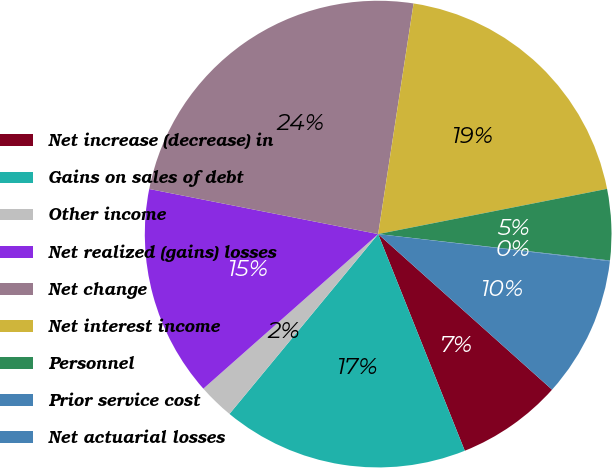Convert chart. <chart><loc_0><loc_0><loc_500><loc_500><pie_chart><fcel>Net increase (decrease) in<fcel>Gains on sales of debt<fcel>Other income<fcel>Net realized (gains) losses<fcel>Net change<fcel>Net interest income<fcel>Personnel<fcel>Prior service cost<fcel>Net actuarial losses<nl><fcel>7.33%<fcel>17.05%<fcel>2.48%<fcel>14.62%<fcel>24.33%<fcel>19.47%<fcel>4.91%<fcel>0.05%<fcel>9.76%<nl></chart> 